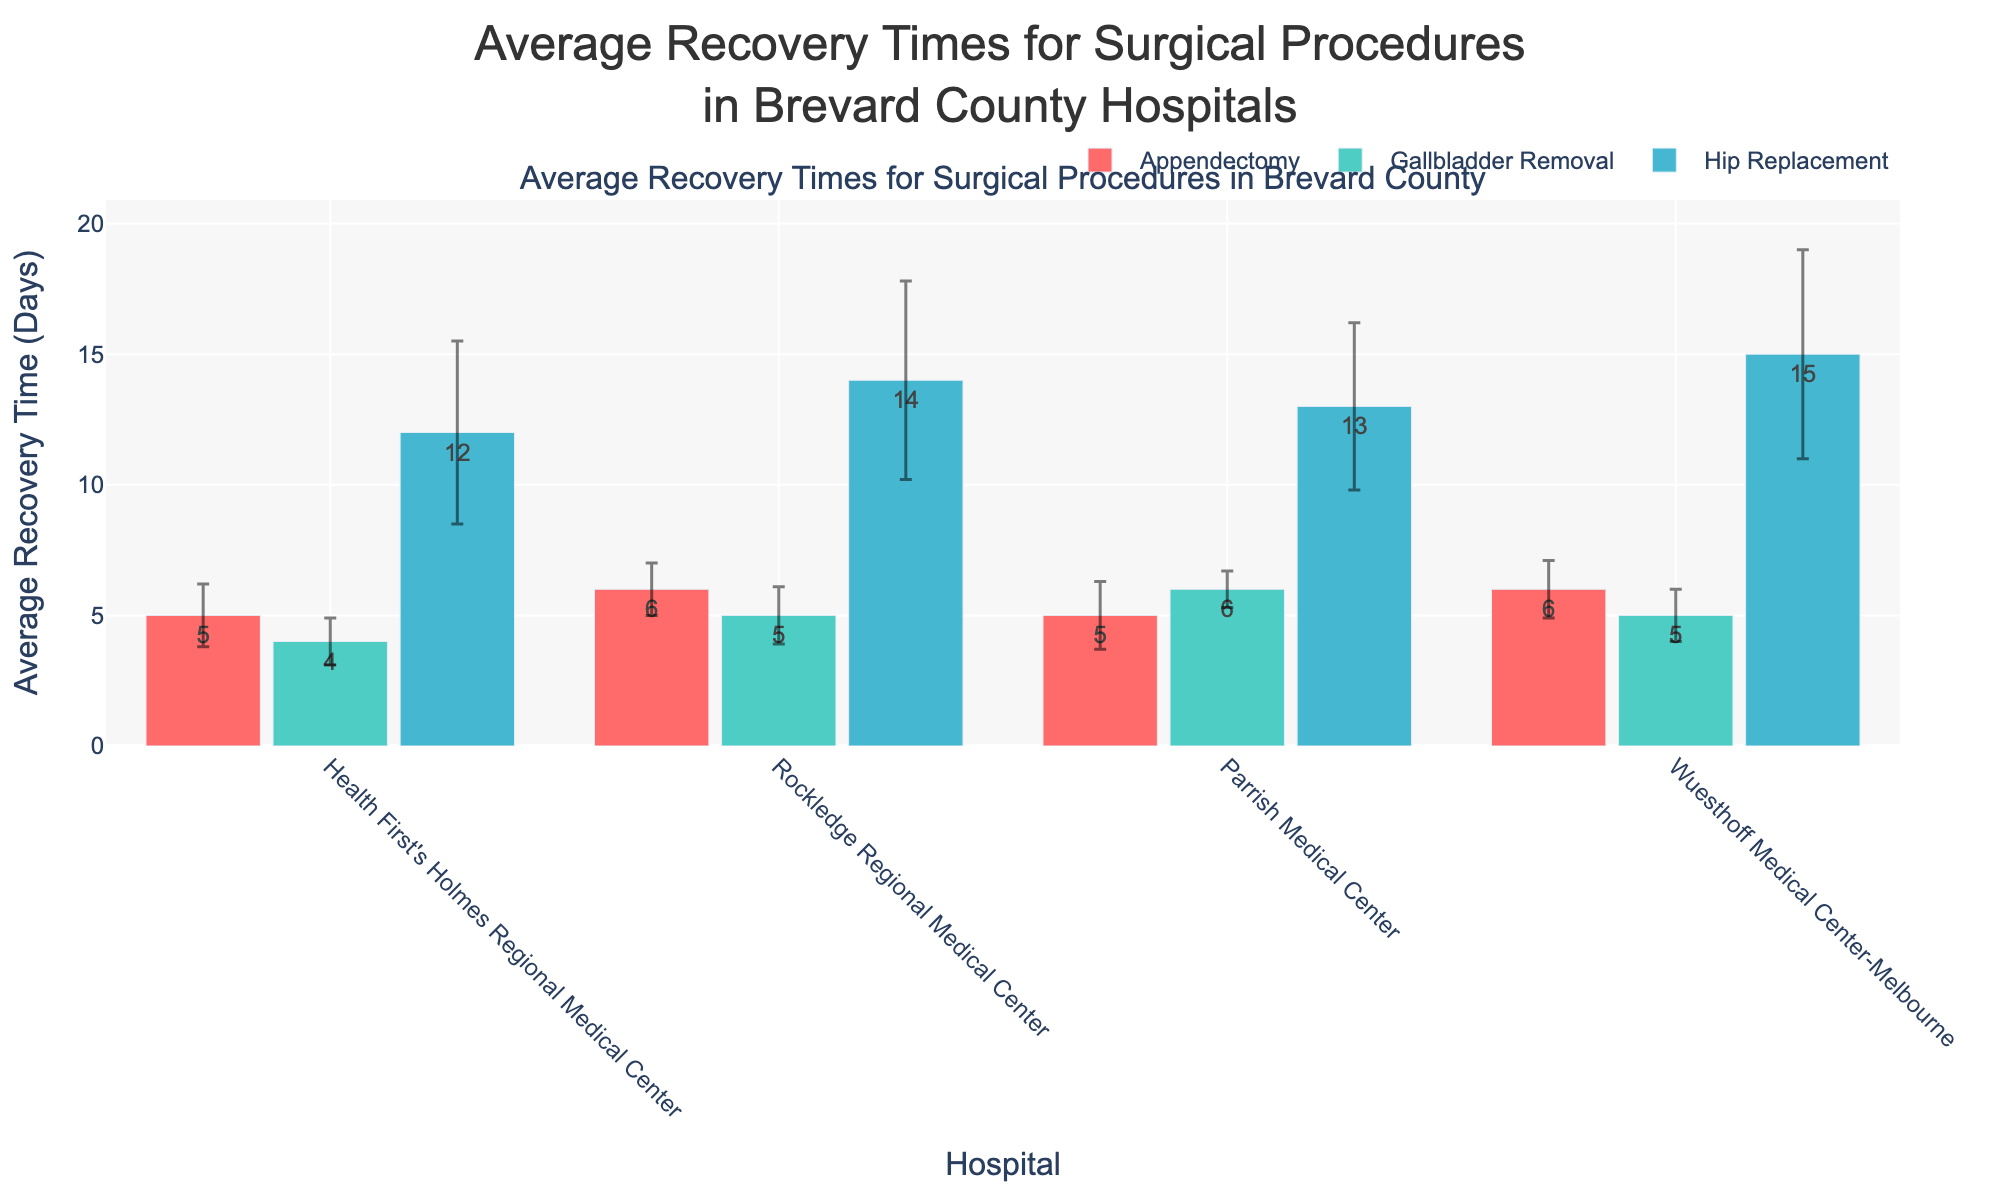What's the average recovery time for a Gallbladder Removal at Rockledge Regional Medical Center? To find this information, look at the bar corresponding to Gallbladder Removal for Rockledge Regional Medical Center, which shows the average recovery time
Answer: 5 days Which hospital has the highest average recovery time for Hip Replacement? To determine this, compare the heights of the bars for Hip Replacement across all hospitals. Wuesthoff Medical Center-Melbourne has the tallest bar.
Answer: Wuesthoff Medical Center-Melbourne What is the difference in average recovery time for an Appendectomy between Rockledge Regional Medical Center and Health First's Holmes Regional Medical Center? Subtract the average recovery time for an Appendectomy at Health First's Holmes Regional Medical Center from Rockledge Regional Medical Center. Rockledge Regional (6 days) - Health First's Holmes (5 days)
Answer: 1 day Which surgical procedure has the smallest variation in recovery times at Parrish Medical Center? The smallest variation (standard deviation) can be determined by looking at the smallest error bar among the procedures at Parrish Medical Center. For Parrish Medical Center, the Gallbladder Removal has the smallest error bar with 0.7 days.
Answer: Gallbladder Removal Is the standard deviation for Hip Replacement recovery times larger for Rockledge Regional Medical Center or Health First's Holmes Regional Medical Center? Compare the sizes of the error bars for Hip Replacement between these two hospitals. Rockledge Regional Medical Center (3.8 days) has a larger error bar than Health First's Holmes Regional Medical Center (3.5 days).
Answer: Rockledge Regional Medical Center What is the average recovery time for Appendectomy across all hospitals in Brevard County? Add the average recovery times for Appendectomy at all hospitals and then divide by the number of hospitals. (5 + 6 + 5 + 6) / 4 = 22 / 4 = 5.5 days
Answer: 5.5 days Which hospital has the least average recovery time for a Gallbladder Removal, and what is it? Compare the average recovery times for Gallbladder Removal for all hospitals. Health First's Holmes Regional Medical Center has the least recovery time of 4 days.
Answer: Health First's Holmes Regional Medical Center, 4 days What is the total range of average recovery times for Hip Replacement across all hospitals in Brevard County? Identify the maximum and minimum average recovery times for Hip Replacement and subtract the minimum from the maximum. Maximum (Wuesthoff Medical Center-Melbourne, 15 days) - Minimum (Health First's Holmes Regional Medical Center, 12 days) = 15 - 12 = 3 days
Answer: 3 days 